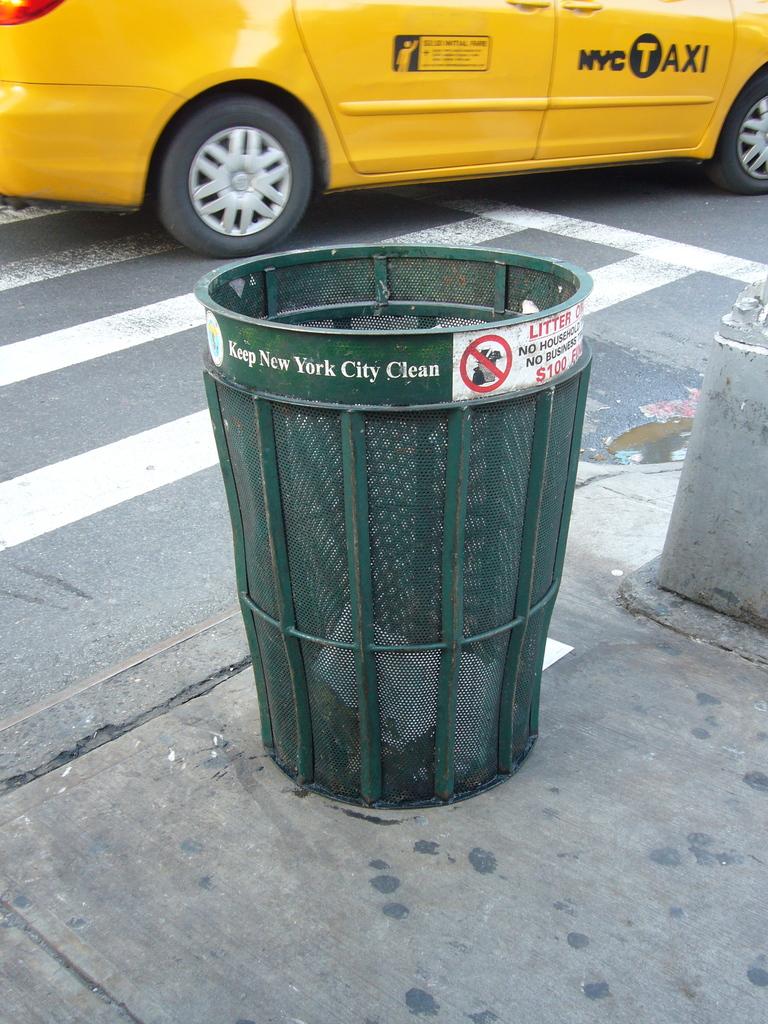Which city is this trash bin from?
Make the answer very short. New york city. Does the can say to keep the city clean?
Make the answer very short. Yes. 